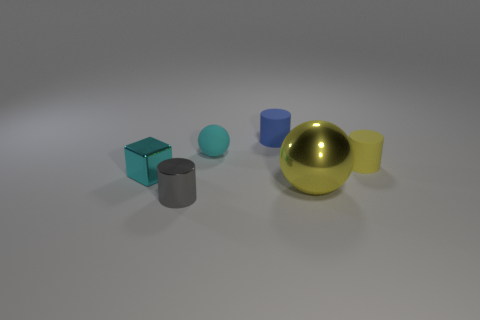Are there fewer tiny cyan cubes than rubber objects?
Your answer should be very brief. Yes. What number of small matte balls have the same color as the block?
Your answer should be compact. 1. There is a thing that is the same color as the small matte ball; what material is it?
Offer a terse response. Metal. There is a small shiny cube; does it have the same color as the tiny metal object that is in front of the cube?
Provide a short and direct response. No. Are there more tiny metallic things than tiny yellow matte cylinders?
Your answer should be compact. Yes. The other thing that is the same shape as the tiny cyan rubber object is what size?
Provide a short and direct response. Large. Is the cyan block made of the same material as the cylinder that is behind the small yellow object?
Provide a short and direct response. No. How many objects are either blue rubber things or small cyan rubber objects?
Give a very brief answer. 2. There is a rubber cylinder in front of the blue matte thing; is its size the same as the ball right of the blue rubber cylinder?
Keep it short and to the point. No. How many spheres are either large yellow things or tiny cyan metallic objects?
Your response must be concise. 1. 